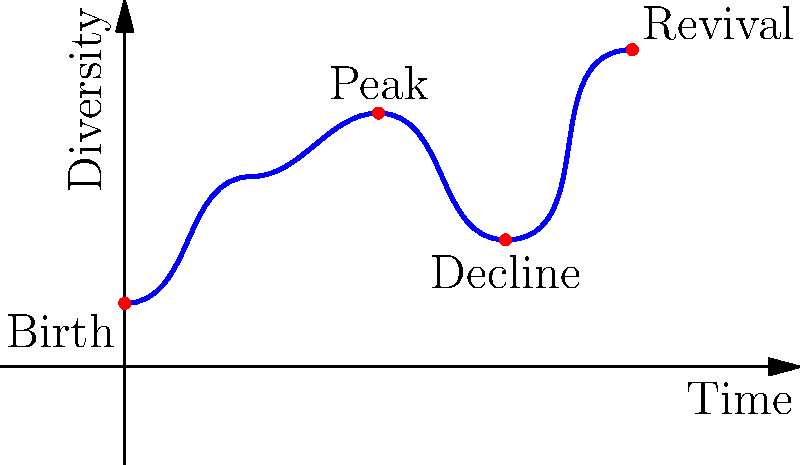Consider the topological space $X$ represented by the curve in the graph, which depicts the evolution of UK indie music diversity over time. What are the homology groups $H_0(X)$ and $H_1(X)$ of this space? To determine the homology groups of the space $X$, we need to analyze its topological properties:

1. Connectivity: The space $X$ is represented by a single continuous curve, which means it's path-connected.

2. Holes: The curve doesn't form any closed loops, so there are no 1-dimensional holes.

3. Components: There is only one connected component in the space.

Now, let's consider the homology groups:

1. $H_0(X)$: This group represents the number of path-connected components in the space. Since $X$ is a single continuous curve, there is only one component.

   $H_0(X) \cong \mathbb{Z}$

2. $H_1(X)$: This group represents the number of 1-dimensional holes (loops) in the space. As the curve doesn't form any closed loops, there are no 1-dimensional holes.

   $H_1(X) \cong 0$

Higher homology groups ($H_n(X)$ for $n \geq 2$) are all trivial (0) because the space is essentially 1-dimensional.
Answer: $H_0(X) \cong \mathbb{Z}$, $H_1(X) \cong 0$ 